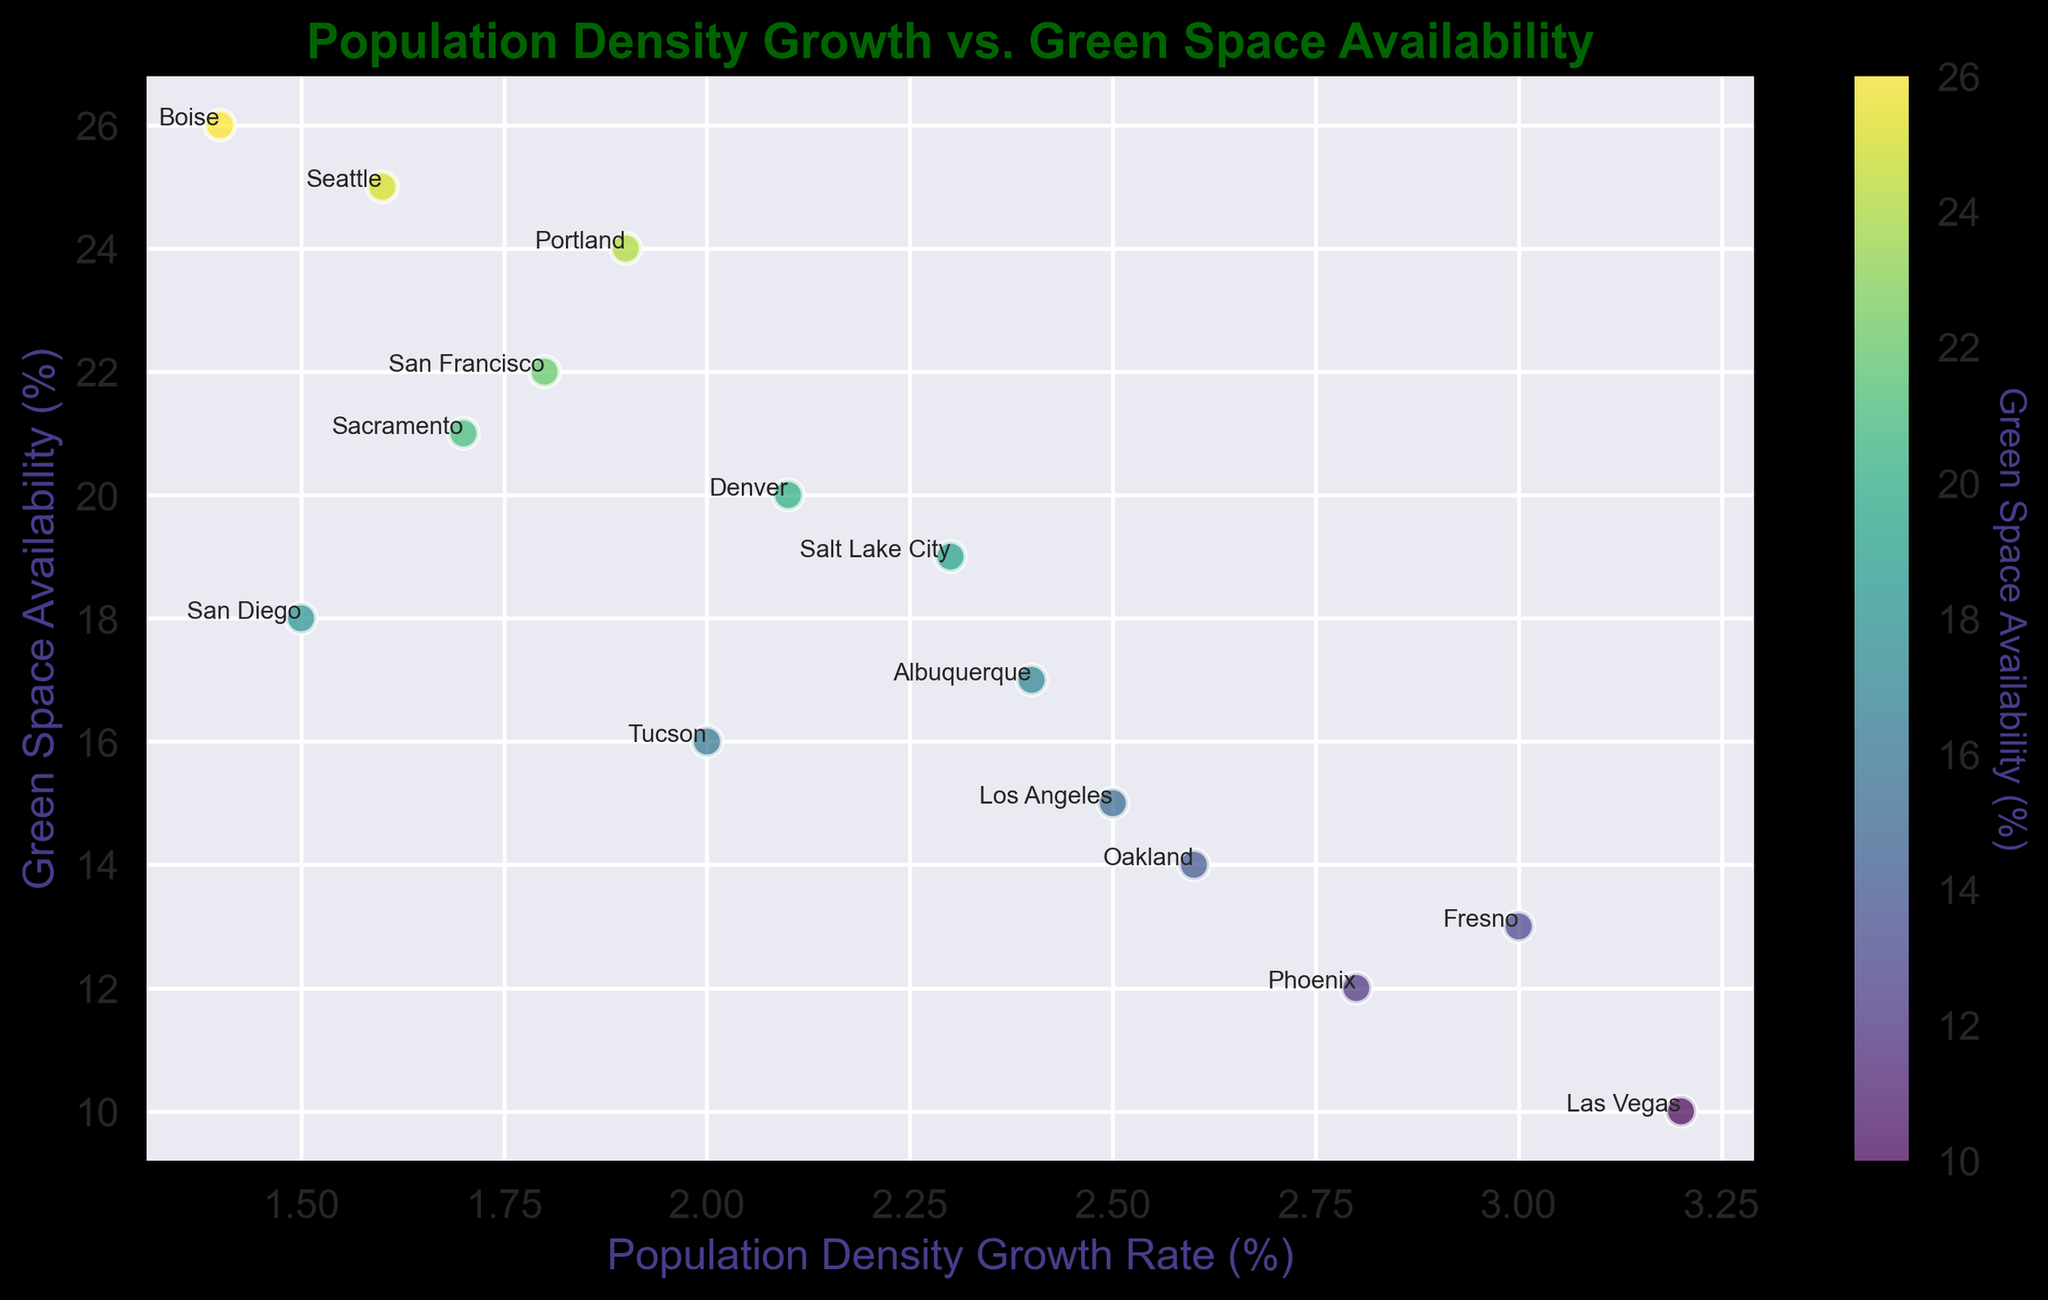Which city has the highest population density growth rate? Locate the point on the scatter plot with the highest x-coordinate value. Identify the city label associated with this point.
Answer: Las Vegas Which city has the lowest availability of green spaces? Locate the point on the scatter plot with the lowest y-coordinate value. Identify the city label associated with this point.
Answer: Las Vegas What is the difference in green space availability between Seattle and Los Angeles? Find and note the green space availability percentages for both cities from the plot. Calculate the difference by subtracting the value for Los Angeles from that for Seattle: 25% - 15% = 10%
Answer: 10% Which cities have a population density growth rate greater than or equal to 2.5%? Identify the points on the scatter plot where the x-coordinate is 2.5% or higher. Check the city labels for these points.
Answer: Los Angeles, Las Vegas, Phoenix, Oakland, Fresno Which city has a population density growth rate of 1.6%? Locate the point on the scatter plot with an x-coordinate of 1.6%. Check the city label associated with this point.
Answer: Seattle Is there a noticeable trend between cities with higher population density growth rates and green space availability? Observe the general distribution of points. Determine if there is a visible upward or downward trend or if the points are scattered without any noticeable pattern.
Answer: Higher population density growth rates tend to correlate with lower green space availability 